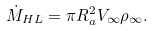Convert formula to latex. <formula><loc_0><loc_0><loc_500><loc_500>\dot { M } _ { H L } = \pi R _ { a } ^ { 2 } V _ { \infty } \rho _ { \infty } .</formula> 